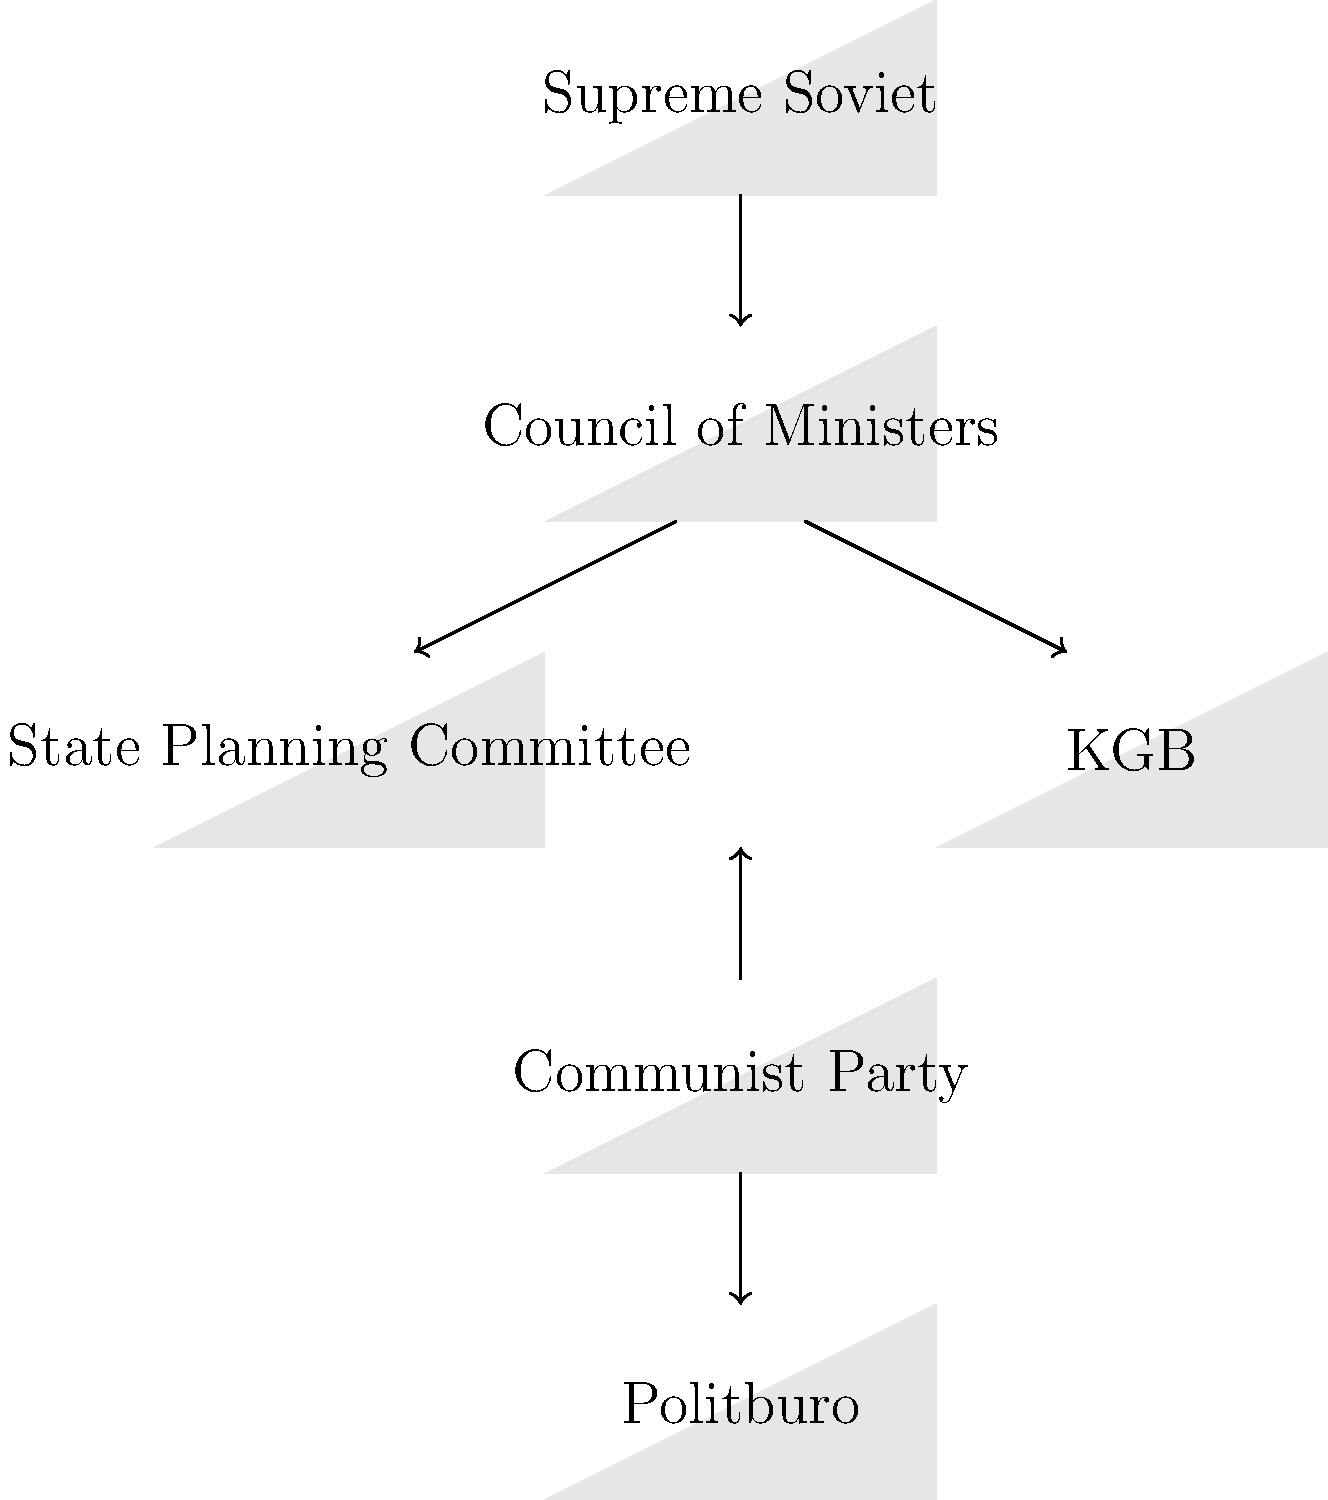In the Soviet government structure, which body was responsible for both state security and intelligence operations, and where was it positioned in relation to the Council of Ministers? To answer this question, let's analyze the infographic step-by-step:

1. The top of the hierarchy shows the Supreme Soviet, which was the highest legislative body.

2. Directly below the Supreme Soviet is the Council of Ministers, which was the executive branch of the government.

3. Below the Council of Ministers, we see two bodies connected by arrows:
   a) On the left: State Planning Committee
   b) On the right: KGB

4. The KGB (Komitet Gosudarstvennoy Bezopasnosti) was indeed responsible for both state security and intelligence operations in the Soviet Union.

5. The position of the KGB in the diagram shows that it was directly subordinate to the Council of Ministers, as indicated by the arrow connecting them.

6. This placement reflects the historical reality that the KGB, while a powerful organization, was officially under the control of the Soviet government's executive branch.

7. It's worth noting that the Communist Party and Politburo are shown at the bottom of the diagram, reflecting their overarching influence on all state institutions, including the KGB.

Based on this analysis, we can conclude that the KGB was responsible for state security and intelligence, and it was positioned directly under the Council of Ministers in the Soviet governmental structure.
Answer: KGB, positioned directly under the Council of Ministers 